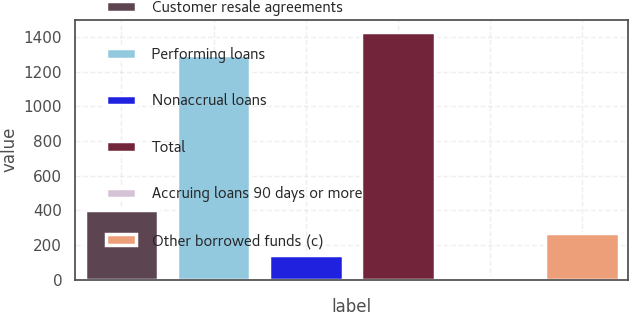Convert chart to OTSL. <chart><loc_0><loc_0><loc_500><loc_500><bar_chart><fcel>Customer resale agreements<fcel>Performing loans<fcel>Nonaccrual loans<fcel>Total<fcel>Accruing loans 90 days or more<fcel>Other borrowed funds (c)<nl><fcel>400.1<fcel>1298<fcel>138.7<fcel>1428.7<fcel>8<fcel>269.4<nl></chart> 